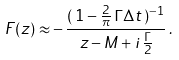Convert formula to latex. <formula><loc_0><loc_0><loc_500><loc_500>F ( z ) \approx - \, \frac { ( \, 1 - \frac { 2 } { \pi } \, \Gamma \Delta t \, ) ^ { - 1 } } { z - M + i \, \frac { \Gamma } { 2 } } \, .</formula> 